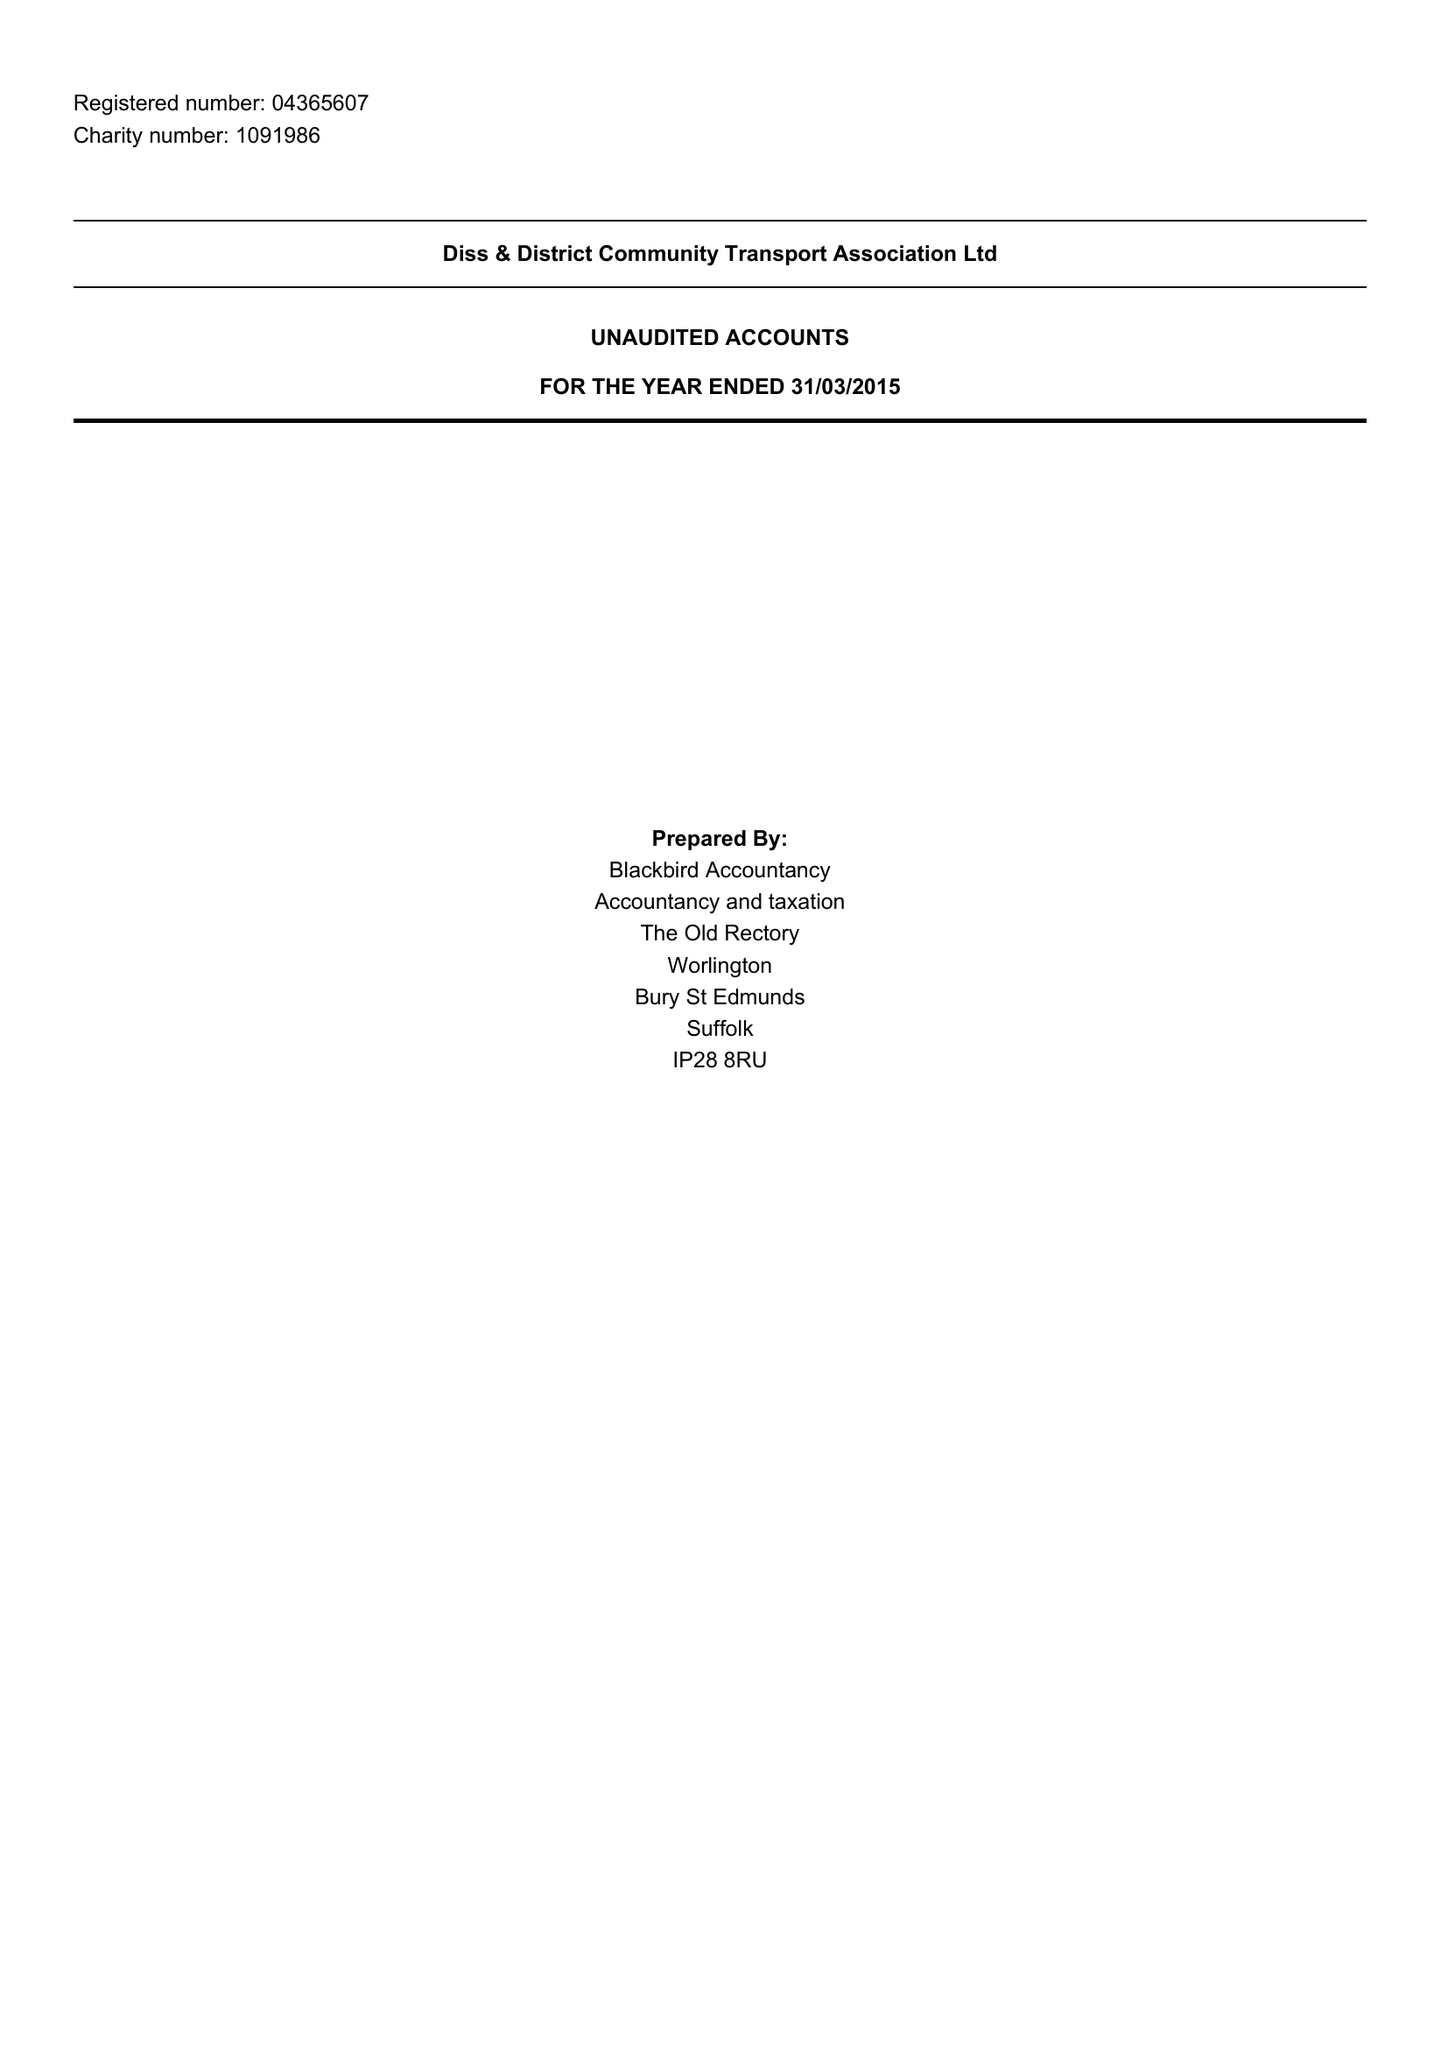What is the value for the report_date?
Answer the question using a single word or phrase. 2015-03-31 